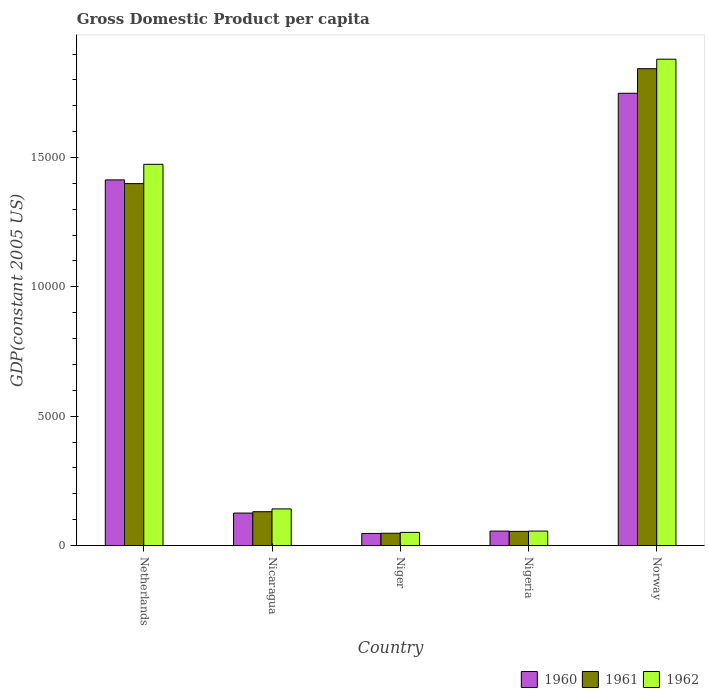How many different coloured bars are there?
Offer a very short reply. 3. Are the number of bars on each tick of the X-axis equal?
Give a very brief answer. Yes. How many bars are there on the 2nd tick from the left?
Give a very brief answer. 3. What is the label of the 4th group of bars from the left?
Provide a succinct answer. Nigeria. What is the GDP per capita in 1961 in Nigeria?
Keep it short and to the point. 548.94. Across all countries, what is the maximum GDP per capita in 1961?
Make the answer very short. 1.84e+04. Across all countries, what is the minimum GDP per capita in 1960?
Your answer should be compact. 468.22. In which country was the GDP per capita in 1960 maximum?
Give a very brief answer. Norway. In which country was the GDP per capita in 1962 minimum?
Provide a short and direct response. Niger. What is the total GDP per capita in 1961 in the graph?
Provide a succinct answer. 3.48e+04. What is the difference between the GDP per capita in 1960 in Nicaragua and that in Nigeria?
Your answer should be very brief. 696.83. What is the difference between the GDP per capita in 1962 in Norway and the GDP per capita in 1960 in Netherlands?
Make the answer very short. 4666.1. What is the average GDP per capita in 1962 per country?
Offer a very short reply. 7204.86. What is the difference between the GDP per capita of/in 1960 and GDP per capita of/in 1961 in Nicaragua?
Provide a short and direct response. -51.9. What is the ratio of the GDP per capita in 1960 in Netherlands to that in Niger?
Make the answer very short. 30.19. Is the GDP per capita in 1961 in Niger less than that in Nigeria?
Offer a very short reply. Yes. What is the difference between the highest and the second highest GDP per capita in 1962?
Your answer should be very brief. 4063.52. What is the difference between the highest and the lowest GDP per capita in 1962?
Your answer should be compact. 1.83e+04. Is the sum of the GDP per capita in 1960 in Niger and Nigeria greater than the maximum GDP per capita in 1962 across all countries?
Provide a short and direct response. No. What does the 1st bar from the right in Norway represents?
Keep it short and to the point. 1962. How many bars are there?
Your response must be concise. 15. Are all the bars in the graph horizontal?
Offer a very short reply. No. How many countries are there in the graph?
Offer a terse response. 5. Does the graph contain any zero values?
Ensure brevity in your answer.  No. Does the graph contain grids?
Ensure brevity in your answer.  No. Where does the legend appear in the graph?
Make the answer very short. Bottom right. How many legend labels are there?
Your answer should be compact. 3. What is the title of the graph?
Your response must be concise. Gross Domestic Product per capita. What is the label or title of the Y-axis?
Your response must be concise. GDP(constant 2005 US). What is the GDP(constant 2005 US) in 1960 in Netherlands?
Provide a succinct answer. 1.41e+04. What is the GDP(constant 2005 US) in 1961 in Netherlands?
Offer a very short reply. 1.40e+04. What is the GDP(constant 2005 US) in 1962 in Netherlands?
Offer a terse response. 1.47e+04. What is the GDP(constant 2005 US) in 1960 in Nicaragua?
Ensure brevity in your answer.  1256.03. What is the GDP(constant 2005 US) in 1961 in Nicaragua?
Provide a short and direct response. 1307.92. What is the GDP(constant 2005 US) in 1962 in Nicaragua?
Offer a very short reply. 1417.4. What is the GDP(constant 2005 US) in 1960 in Niger?
Keep it short and to the point. 468.22. What is the GDP(constant 2005 US) in 1961 in Niger?
Your answer should be very brief. 475.72. What is the GDP(constant 2005 US) of 1962 in Niger?
Offer a very short reply. 509.6. What is the GDP(constant 2005 US) in 1960 in Nigeria?
Keep it short and to the point. 559.19. What is the GDP(constant 2005 US) of 1961 in Nigeria?
Your answer should be compact. 548.94. What is the GDP(constant 2005 US) of 1962 in Nigeria?
Make the answer very short. 559.66. What is the GDP(constant 2005 US) in 1960 in Norway?
Keep it short and to the point. 1.75e+04. What is the GDP(constant 2005 US) of 1961 in Norway?
Provide a short and direct response. 1.84e+04. What is the GDP(constant 2005 US) in 1962 in Norway?
Your answer should be very brief. 1.88e+04. Across all countries, what is the maximum GDP(constant 2005 US) in 1960?
Provide a short and direct response. 1.75e+04. Across all countries, what is the maximum GDP(constant 2005 US) in 1961?
Provide a short and direct response. 1.84e+04. Across all countries, what is the maximum GDP(constant 2005 US) in 1962?
Offer a very short reply. 1.88e+04. Across all countries, what is the minimum GDP(constant 2005 US) of 1960?
Give a very brief answer. 468.22. Across all countries, what is the minimum GDP(constant 2005 US) in 1961?
Keep it short and to the point. 475.72. Across all countries, what is the minimum GDP(constant 2005 US) in 1962?
Offer a very short reply. 509.6. What is the total GDP(constant 2005 US) of 1960 in the graph?
Your answer should be compact. 3.39e+04. What is the total GDP(constant 2005 US) of 1961 in the graph?
Offer a terse response. 3.48e+04. What is the total GDP(constant 2005 US) of 1962 in the graph?
Keep it short and to the point. 3.60e+04. What is the difference between the GDP(constant 2005 US) of 1960 in Netherlands and that in Nicaragua?
Provide a short and direct response. 1.29e+04. What is the difference between the GDP(constant 2005 US) of 1961 in Netherlands and that in Nicaragua?
Your answer should be very brief. 1.27e+04. What is the difference between the GDP(constant 2005 US) of 1962 in Netherlands and that in Nicaragua?
Your answer should be compact. 1.33e+04. What is the difference between the GDP(constant 2005 US) in 1960 in Netherlands and that in Niger?
Provide a succinct answer. 1.37e+04. What is the difference between the GDP(constant 2005 US) of 1961 in Netherlands and that in Niger?
Provide a short and direct response. 1.35e+04. What is the difference between the GDP(constant 2005 US) in 1962 in Netherlands and that in Niger?
Give a very brief answer. 1.42e+04. What is the difference between the GDP(constant 2005 US) of 1960 in Netherlands and that in Nigeria?
Keep it short and to the point. 1.36e+04. What is the difference between the GDP(constant 2005 US) of 1961 in Netherlands and that in Nigeria?
Give a very brief answer. 1.34e+04. What is the difference between the GDP(constant 2005 US) of 1962 in Netherlands and that in Nigeria?
Offer a terse response. 1.42e+04. What is the difference between the GDP(constant 2005 US) in 1960 in Netherlands and that in Norway?
Keep it short and to the point. -3349.24. What is the difference between the GDP(constant 2005 US) of 1961 in Netherlands and that in Norway?
Your answer should be compact. -4442.51. What is the difference between the GDP(constant 2005 US) in 1962 in Netherlands and that in Norway?
Give a very brief answer. -4063.52. What is the difference between the GDP(constant 2005 US) in 1960 in Nicaragua and that in Niger?
Offer a very short reply. 787.8. What is the difference between the GDP(constant 2005 US) in 1961 in Nicaragua and that in Niger?
Provide a short and direct response. 832.2. What is the difference between the GDP(constant 2005 US) of 1962 in Nicaragua and that in Niger?
Offer a very short reply. 907.8. What is the difference between the GDP(constant 2005 US) of 1960 in Nicaragua and that in Nigeria?
Your answer should be very brief. 696.83. What is the difference between the GDP(constant 2005 US) in 1961 in Nicaragua and that in Nigeria?
Ensure brevity in your answer.  758.98. What is the difference between the GDP(constant 2005 US) of 1962 in Nicaragua and that in Nigeria?
Ensure brevity in your answer.  857.74. What is the difference between the GDP(constant 2005 US) in 1960 in Nicaragua and that in Norway?
Make the answer very short. -1.62e+04. What is the difference between the GDP(constant 2005 US) of 1961 in Nicaragua and that in Norway?
Offer a terse response. -1.71e+04. What is the difference between the GDP(constant 2005 US) of 1962 in Nicaragua and that in Norway?
Make the answer very short. -1.74e+04. What is the difference between the GDP(constant 2005 US) in 1960 in Niger and that in Nigeria?
Offer a very short reply. -90.97. What is the difference between the GDP(constant 2005 US) in 1961 in Niger and that in Nigeria?
Provide a short and direct response. -73.22. What is the difference between the GDP(constant 2005 US) in 1962 in Niger and that in Nigeria?
Keep it short and to the point. -50.06. What is the difference between the GDP(constant 2005 US) of 1960 in Niger and that in Norway?
Your response must be concise. -1.70e+04. What is the difference between the GDP(constant 2005 US) of 1961 in Niger and that in Norway?
Give a very brief answer. -1.80e+04. What is the difference between the GDP(constant 2005 US) in 1962 in Niger and that in Norway?
Your answer should be compact. -1.83e+04. What is the difference between the GDP(constant 2005 US) of 1960 in Nigeria and that in Norway?
Offer a very short reply. -1.69e+04. What is the difference between the GDP(constant 2005 US) in 1961 in Nigeria and that in Norway?
Make the answer very short. -1.79e+04. What is the difference between the GDP(constant 2005 US) of 1962 in Nigeria and that in Norway?
Make the answer very short. -1.82e+04. What is the difference between the GDP(constant 2005 US) in 1960 in Netherlands and the GDP(constant 2005 US) in 1961 in Nicaragua?
Provide a succinct answer. 1.28e+04. What is the difference between the GDP(constant 2005 US) in 1960 in Netherlands and the GDP(constant 2005 US) in 1962 in Nicaragua?
Keep it short and to the point. 1.27e+04. What is the difference between the GDP(constant 2005 US) of 1961 in Netherlands and the GDP(constant 2005 US) of 1962 in Nicaragua?
Make the answer very short. 1.26e+04. What is the difference between the GDP(constant 2005 US) of 1960 in Netherlands and the GDP(constant 2005 US) of 1961 in Niger?
Ensure brevity in your answer.  1.37e+04. What is the difference between the GDP(constant 2005 US) of 1960 in Netherlands and the GDP(constant 2005 US) of 1962 in Niger?
Ensure brevity in your answer.  1.36e+04. What is the difference between the GDP(constant 2005 US) in 1961 in Netherlands and the GDP(constant 2005 US) in 1962 in Niger?
Your answer should be compact. 1.35e+04. What is the difference between the GDP(constant 2005 US) of 1960 in Netherlands and the GDP(constant 2005 US) of 1961 in Nigeria?
Make the answer very short. 1.36e+04. What is the difference between the GDP(constant 2005 US) in 1960 in Netherlands and the GDP(constant 2005 US) in 1962 in Nigeria?
Give a very brief answer. 1.36e+04. What is the difference between the GDP(constant 2005 US) of 1961 in Netherlands and the GDP(constant 2005 US) of 1962 in Nigeria?
Provide a short and direct response. 1.34e+04. What is the difference between the GDP(constant 2005 US) of 1960 in Netherlands and the GDP(constant 2005 US) of 1961 in Norway?
Give a very brief answer. -4299.05. What is the difference between the GDP(constant 2005 US) of 1960 in Netherlands and the GDP(constant 2005 US) of 1962 in Norway?
Your answer should be very brief. -4666.1. What is the difference between the GDP(constant 2005 US) in 1961 in Netherlands and the GDP(constant 2005 US) in 1962 in Norway?
Your response must be concise. -4809.57. What is the difference between the GDP(constant 2005 US) in 1960 in Nicaragua and the GDP(constant 2005 US) in 1961 in Niger?
Your response must be concise. 780.3. What is the difference between the GDP(constant 2005 US) of 1960 in Nicaragua and the GDP(constant 2005 US) of 1962 in Niger?
Your answer should be compact. 746.43. What is the difference between the GDP(constant 2005 US) of 1961 in Nicaragua and the GDP(constant 2005 US) of 1962 in Niger?
Give a very brief answer. 798.32. What is the difference between the GDP(constant 2005 US) of 1960 in Nicaragua and the GDP(constant 2005 US) of 1961 in Nigeria?
Keep it short and to the point. 707.08. What is the difference between the GDP(constant 2005 US) in 1960 in Nicaragua and the GDP(constant 2005 US) in 1962 in Nigeria?
Your response must be concise. 696.37. What is the difference between the GDP(constant 2005 US) in 1961 in Nicaragua and the GDP(constant 2005 US) in 1962 in Nigeria?
Your response must be concise. 748.26. What is the difference between the GDP(constant 2005 US) in 1960 in Nicaragua and the GDP(constant 2005 US) in 1961 in Norway?
Give a very brief answer. -1.72e+04. What is the difference between the GDP(constant 2005 US) of 1960 in Nicaragua and the GDP(constant 2005 US) of 1962 in Norway?
Ensure brevity in your answer.  -1.75e+04. What is the difference between the GDP(constant 2005 US) of 1961 in Nicaragua and the GDP(constant 2005 US) of 1962 in Norway?
Offer a very short reply. -1.75e+04. What is the difference between the GDP(constant 2005 US) of 1960 in Niger and the GDP(constant 2005 US) of 1961 in Nigeria?
Keep it short and to the point. -80.72. What is the difference between the GDP(constant 2005 US) of 1960 in Niger and the GDP(constant 2005 US) of 1962 in Nigeria?
Keep it short and to the point. -91.43. What is the difference between the GDP(constant 2005 US) of 1961 in Niger and the GDP(constant 2005 US) of 1962 in Nigeria?
Your answer should be compact. -83.94. What is the difference between the GDP(constant 2005 US) of 1960 in Niger and the GDP(constant 2005 US) of 1961 in Norway?
Your response must be concise. -1.80e+04. What is the difference between the GDP(constant 2005 US) in 1960 in Niger and the GDP(constant 2005 US) in 1962 in Norway?
Your answer should be very brief. -1.83e+04. What is the difference between the GDP(constant 2005 US) in 1961 in Niger and the GDP(constant 2005 US) in 1962 in Norway?
Give a very brief answer. -1.83e+04. What is the difference between the GDP(constant 2005 US) in 1960 in Nigeria and the GDP(constant 2005 US) in 1961 in Norway?
Your answer should be compact. -1.79e+04. What is the difference between the GDP(constant 2005 US) of 1960 in Nigeria and the GDP(constant 2005 US) of 1962 in Norway?
Offer a terse response. -1.82e+04. What is the difference between the GDP(constant 2005 US) of 1961 in Nigeria and the GDP(constant 2005 US) of 1962 in Norway?
Offer a very short reply. -1.83e+04. What is the average GDP(constant 2005 US) in 1960 per country?
Give a very brief answer. 6780.33. What is the average GDP(constant 2005 US) in 1961 per country?
Offer a terse response. 6951.42. What is the average GDP(constant 2005 US) in 1962 per country?
Your answer should be very brief. 7204.86. What is the difference between the GDP(constant 2005 US) of 1960 and GDP(constant 2005 US) of 1961 in Netherlands?
Keep it short and to the point. 143.46. What is the difference between the GDP(constant 2005 US) in 1960 and GDP(constant 2005 US) in 1962 in Netherlands?
Keep it short and to the point. -602.58. What is the difference between the GDP(constant 2005 US) in 1961 and GDP(constant 2005 US) in 1962 in Netherlands?
Ensure brevity in your answer.  -746.05. What is the difference between the GDP(constant 2005 US) of 1960 and GDP(constant 2005 US) of 1961 in Nicaragua?
Your response must be concise. -51.9. What is the difference between the GDP(constant 2005 US) of 1960 and GDP(constant 2005 US) of 1962 in Nicaragua?
Your answer should be very brief. -161.37. What is the difference between the GDP(constant 2005 US) of 1961 and GDP(constant 2005 US) of 1962 in Nicaragua?
Your answer should be compact. -109.48. What is the difference between the GDP(constant 2005 US) in 1960 and GDP(constant 2005 US) in 1961 in Niger?
Keep it short and to the point. -7.5. What is the difference between the GDP(constant 2005 US) in 1960 and GDP(constant 2005 US) in 1962 in Niger?
Make the answer very short. -41.37. What is the difference between the GDP(constant 2005 US) in 1961 and GDP(constant 2005 US) in 1962 in Niger?
Your answer should be compact. -33.88. What is the difference between the GDP(constant 2005 US) in 1960 and GDP(constant 2005 US) in 1961 in Nigeria?
Your answer should be very brief. 10.25. What is the difference between the GDP(constant 2005 US) of 1960 and GDP(constant 2005 US) of 1962 in Nigeria?
Ensure brevity in your answer.  -0.46. What is the difference between the GDP(constant 2005 US) of 1961 and GDP(constant 2005 US) of 1962 in Nigeria?
Provide a short and direct response. -10.71. What is the difference between the GDP(constant 2005 US) in 1960 and GDP(constant 2005 US) in 1961 in Norway?
Offer a terse response. -949.8. What is the difference between the GDP(constant 2005 US) of 1960 and GDP(constant 2005 US) of 1962 in Norway?
Offer a very short reply. -1316.86. What is the difference between the GDP(constant 2005 US) in 1961 and GDP(constant 2005 US) in 1962 in Norway?
Give a very brief answer. -367.06. What is the ratio of the GDP(constant 2005 US) of 1960 in Netherlands to that in Nicaragua?
Your answer should be compact. 11.25. What is the ratio of the GDP(constant 2005 US) in 1961 in Netherlands to that in Nicaragua?
Your response must be concise. 10.7. What is the ratio of the GDP(constant 2005 US) in 1962 in Netherlands to that in Nicaragua?
Your answer should be very brief. 10.4. What is the ratio of the GDP(constant 2005 US) in 1960 in Netherlands to that in Niger?
Your answer should be very brief. 30.19. What is the ratio of the GDP(constant 2005 US) in 1961 in Netherlands to that in Niger?
Give a very brief answer. 29.41. What is the ratio of the GDP(constant 2005 US) of 1962 in Netherlands to that in Niger?
Offer a very short reply. 28.92. What is the ratio of the GDP(constant 2005 US) of 1960 in Netherlands to that in Nigeria?
Provide a succinct answer. 25.28. What is the ratio of the GDP(constant 2005 US) in 1961 in Netherlands to that in Nigeria?
Give a very brief answer. 25.49. What is the ratio of the GDP(constant 2005 US) in 1962 in Netherlands to that in Nigeria?
Your response must be concise. 26.33. What is the ratio of the GDP(constant 2005 US) of 1960 in Netherlands to that in Norway?
Offer a very short reply. 0.81. What is the ratio of the GDP(constant 2005 US) in 1961 in Netherlands to that in Norway?
Ensure brevity in your answer.  0.76. What is the ratio of the GDP(constant 2005 US) of 1962 in Netherlands to that in Norway?
Ensure brevity in your answer.  0.78. What is the ratio of the GDP(constant 2005 US) in 1960 in Nicaragua to that in Niger?
Ensure brevity in your answer.  2.68. What is the ratio of the GDP(constant 2005 US) in 1961 in Nicaragua to that in Niger?
Offer a very short reply. 2.75. What is the ratio of the GDP(constant 2005 US) of 1962 in Nicaragua to that in Niger?
Offer a terse response. 2.78. What is the ratio of the GDP(constant 2005 US) in 1960 in Nicaragua to that in Nigeria?
Keep it short and to the point. 2.25. What is the ratio of the GDP(constant 2005 US) of 1961 in Nicaragua to that in Nigeria?
Provide a succinct answer. 2.38. What is the ratio of the GDP(constant 2005 US) of 1962 in Nicaragua to that in Nigeria?
Provide a succinct answer. 2.53. What is the ratio of the GDP(constant 2005 US) in 1960 in Nicaragua to that in Norway?
Your answer should be very brief. 0.07. What is the ratio of the GDP(constant 2005 US) of 1961 in Nicaragua to that in Norway?
Your answer should be compact. 0.07. What is the ratio of the GDP(constant 2005 US) in 1962 in Nicaragua to that in Norway?
Your answer should be very brief. 0.08. What is the ratio of the GDP(constant 2005 US) in 1960 in Niger to that in Nigeria?
Offer a terse response. 0.84. What is the ratio of the GDP(constant 2005 US) of 1961 in Niger to that in Nigeria?
Give a very brief answer. 0.87. What is the ratio of the GDP(constant 2005 US) in 1962 in Niger to that in Nigeria?
Your response must be concise. 0.91. What is the ratio of the GDP(constant 2005 US) of 1960 in Niger to that in Norway?
Offer a terse response. 0.03. What is the ratio of the GDP(constant 2005 US) in 1961 in Niger to that in Norway?
Offer a very short reply. 0.03. What is the ratio of the GDP(constant 2005 US) in 1962 in Niger to that in Norway?
Offer a very short reply. 0.03. What is the ratio of the GDP(constant 2005 US) of 1960 in Nigeria to that in Norway?
Your answer should be very brief. 0.03. What is the ratio of the GDP(constant 2005 US) in 1961 in Nigeria to that in Norway?
Ensure brevity in your answer.  0.03. What is the ratio of the GDP(constant 2005 US) of 1962 in Nigeria to that in Norway?
Your response must be concise. 0.03. What is the difference between the highest and the second highest GDP(constant 2005 US) in 1960?
Provide a succinct answer. 3349.24. What is the difference between the highest and the second highest GDP(constant 2005 US) of 1961?
Offer a very short reply. 4442.51. What is the difference between the highest and the second highest GDP(constant 2005 US) in 1962?
Offer a terse response. 4063.52. What is the difference between the highest and the lowest GDP(constant 2005 US) of 1960?
Your response must be concise. 1.70e+04. What is the difference between the highest and the lowest GDP(constant 2005 US) of 1961?
Offer a very short reply. 1.80e+04. What is the difference between the highest and the lowest GDP(constant 2005 US) of 1962?
Your response must be concise. 1.83e+04. 